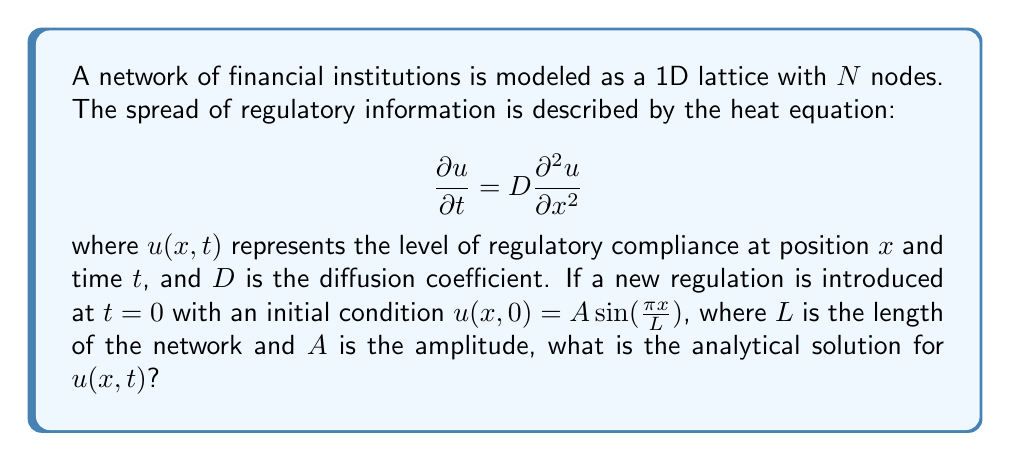Provide a solution to this math problem. To solve this heat equation with the given initial condition, we follow these steps:

1) The general solution for the 1D heat equation with Fourier series is:

   $$u(x,t) = \sum_{n=1}^{\infty} B_n \sin(\frac{n\pi x}{L}) e^{-D(\frac{n\pi}{L})^2 t}$$

2) Our initial condition is:

   $$u(x,0) = A\sin(\frac{\pi x}{L})$$

3) Comparing this with the general solution at $t=0$, we see that only the $n=1$ term is non-zero, with $B_1 = A$ and $B_n = 0$ for $n > 1$.

4) Therefore, our solution simplifies to:

   $$u(x,t) = A \sin(\frac{\pi x}{L}) e^{-D(\frac{\pi}{L})^2 t}$$

5) This is the analytical solution that describes how the regulatory information spreads across the network over time.
Answer: $u(x,t) = A \sin(\frac{\pi x}{L}) e^{-D(\frac{\pi}{L})^2 t}$ 